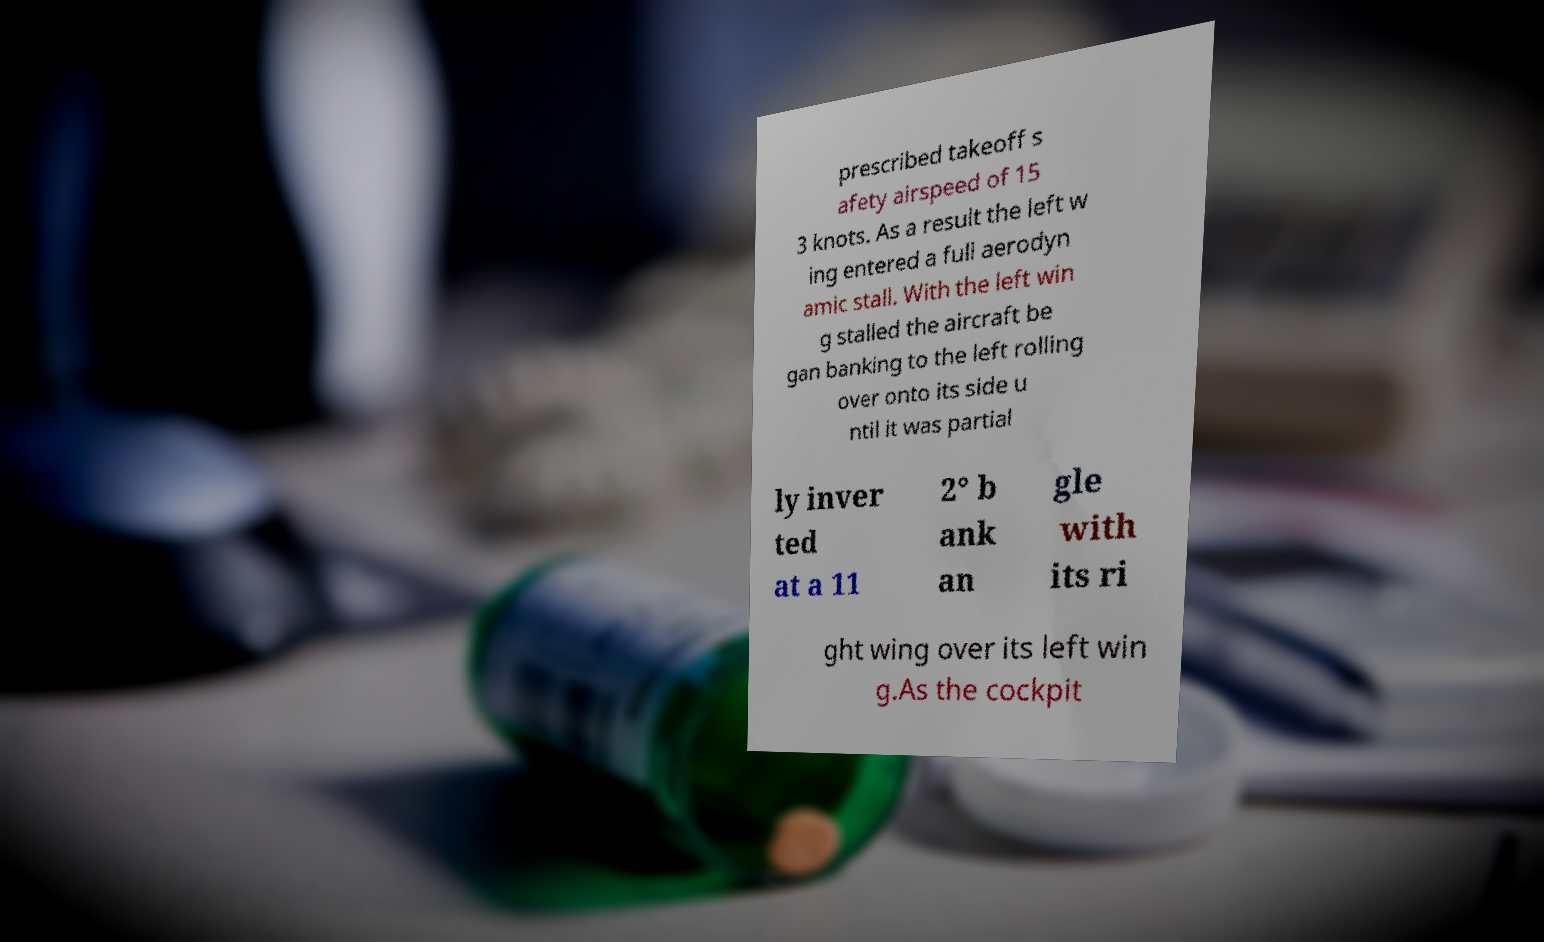I need the written content from this picture converted into text. Can you do that? prescribed takeoff s afety airspeed of 15 3 knots. As a result the left w ing entered a full aerodyn amic stall. With the left win g stalled the aircraft be gan banking to the left rolling over onto its side u ntil it was partial ly inver ted at a 11 2° b ank an gle with its ri ght wing over its left win g.As the cockpit 